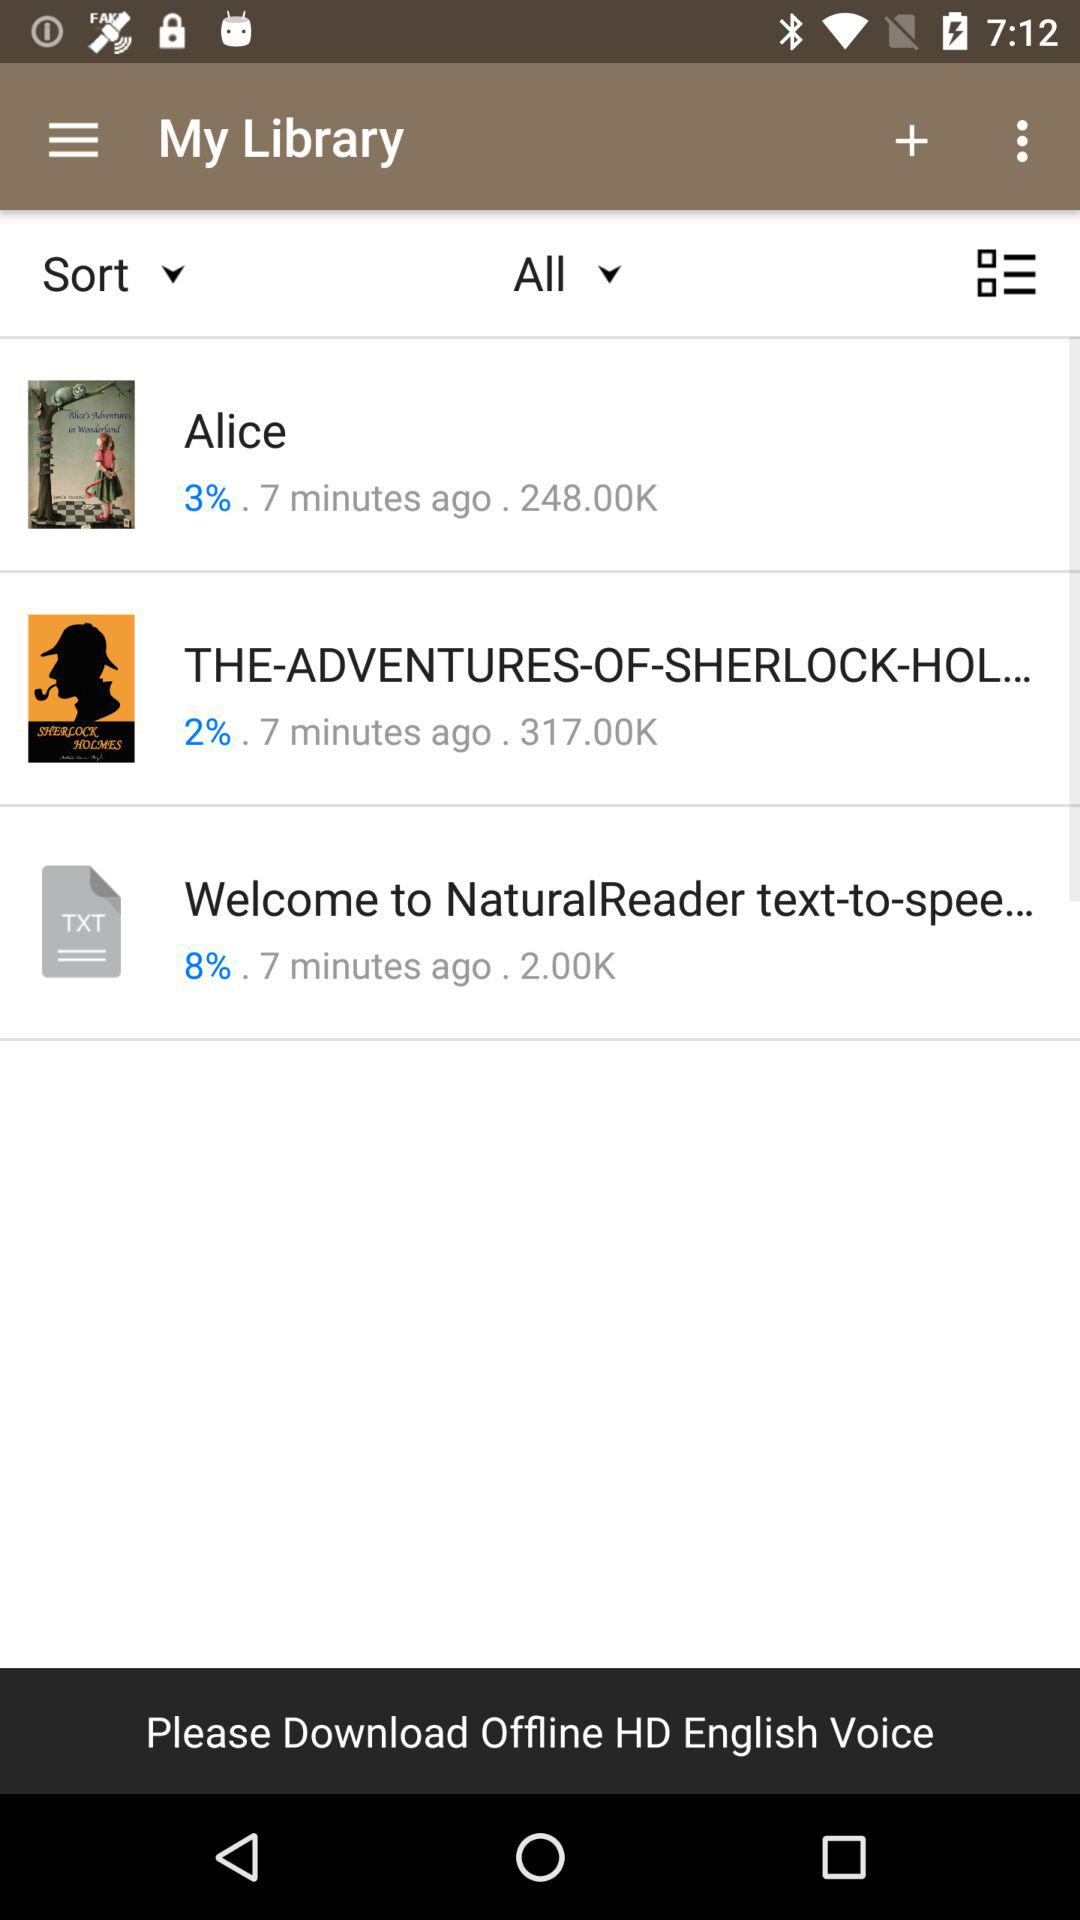When did "Alice" start to download? "Alice" started to download 7 minutes ago. 